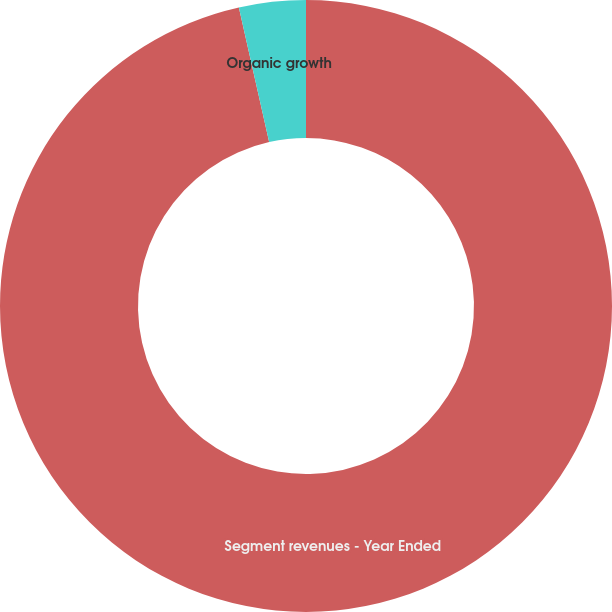Convert chart to OTSL. <chart><loc_0><loc_0><loc_500><loc_500><pie_chart><fcel>Segment revenues - Year Ended<fcel>Organic growth<nl><fcel>96.48%<fcel>3.52%<nl></chart> 